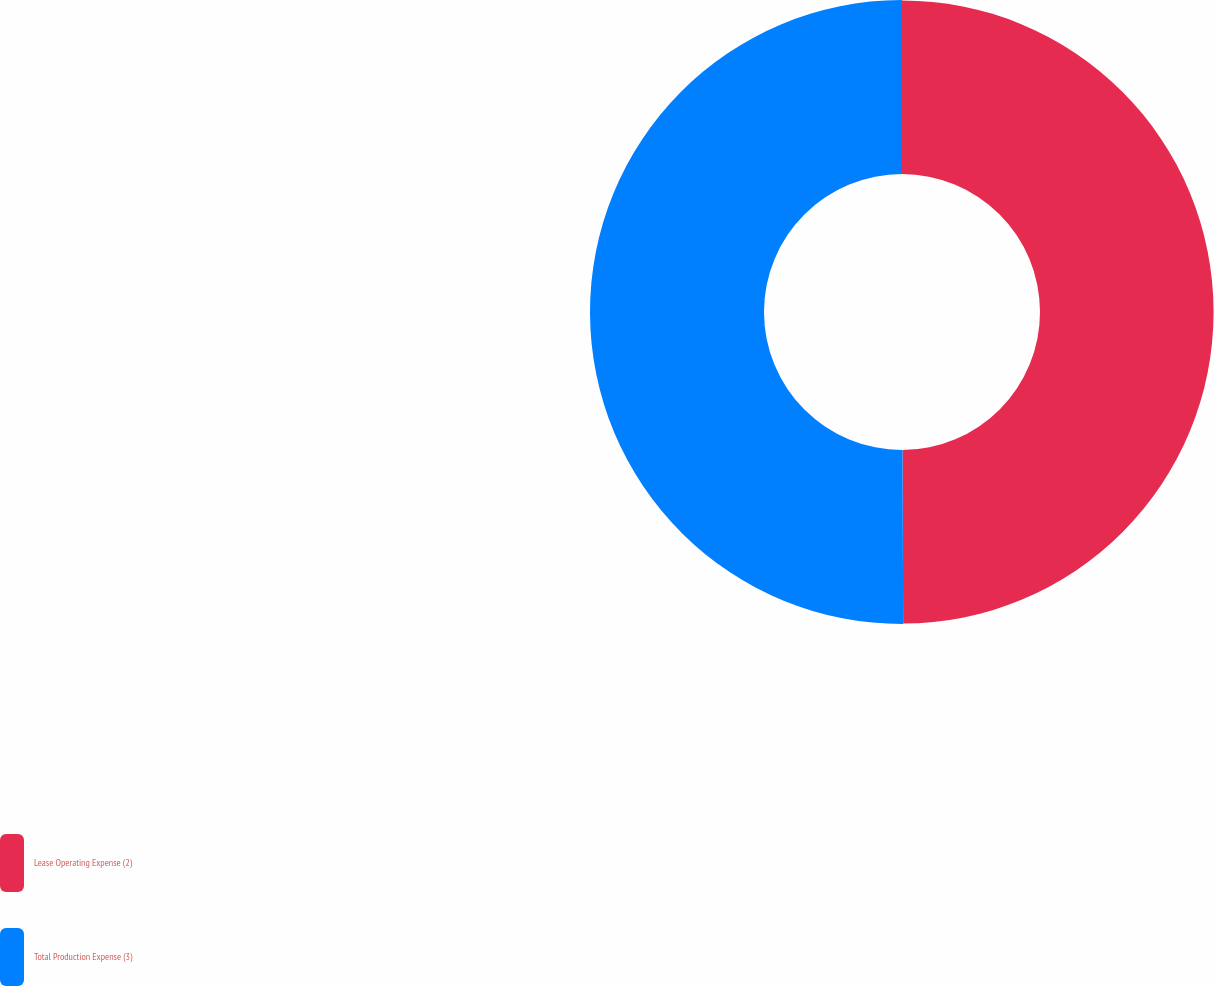<chart> <loc_0><loc_0><loc_500><loc_500><pie_chart><fcel>Lease Operating Expense (2)<fcel>Total Production Expense (3)<nl><fcel>49.94%<fcel>50.06%<nl></chart> 